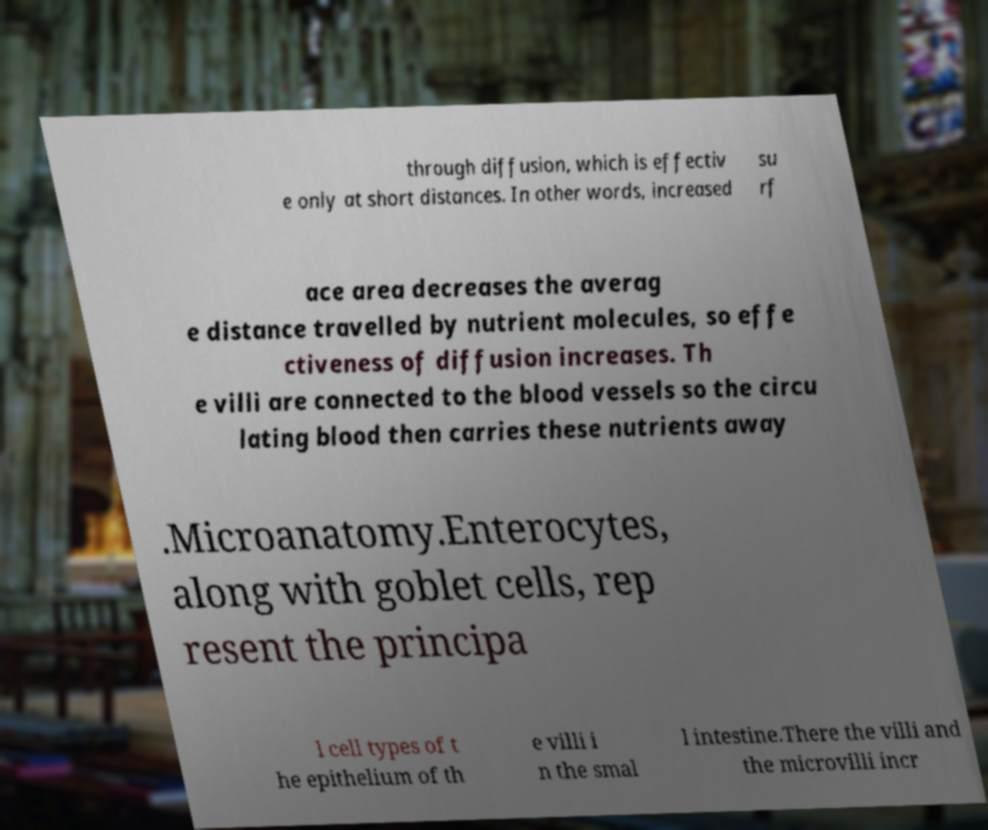Please identify and transcribe the text found in this image. through diffusion, which is effectiv e only at short distances. In other words, increased su rf ace area decreases the averag e distance travelled by nutrient molecules, so effe ctiveness of diffusion increases. Th e villi are connected to the blood vessels so the circu lating blood then carries these nutrients away .Microanatomy.Enterocytes, along with goblet cells, rep resent the principa l cell types of t he epithelium of th e villi i n the smal l intestine.There the villi and the microvilli incr 